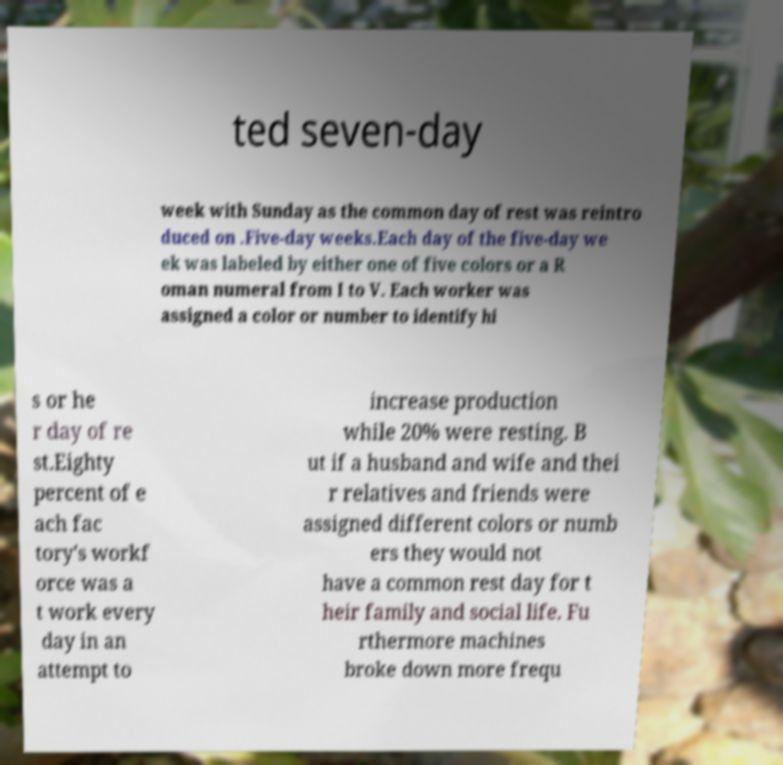Could you extract and type out the text from this image? ted seven-day week with Sunday as the common day of rest was reintro duced on .Five-day weeks.Each day of the five-day we ek was labeled by either one of five colors or a R oman numeral from I to V. Each worker was assigned a color or number to identify hi s or he r day of re st.Eighty percent of e ach fac tory's workf orce was a t work every day in an attempt to increase production while 20% were resting. B ut if a husband and wife and thei r relatives and friends were assigned different colors or numb ers they would not have a common rest day for t heir family and social life. Fu rthermore machines broke down more frequ 